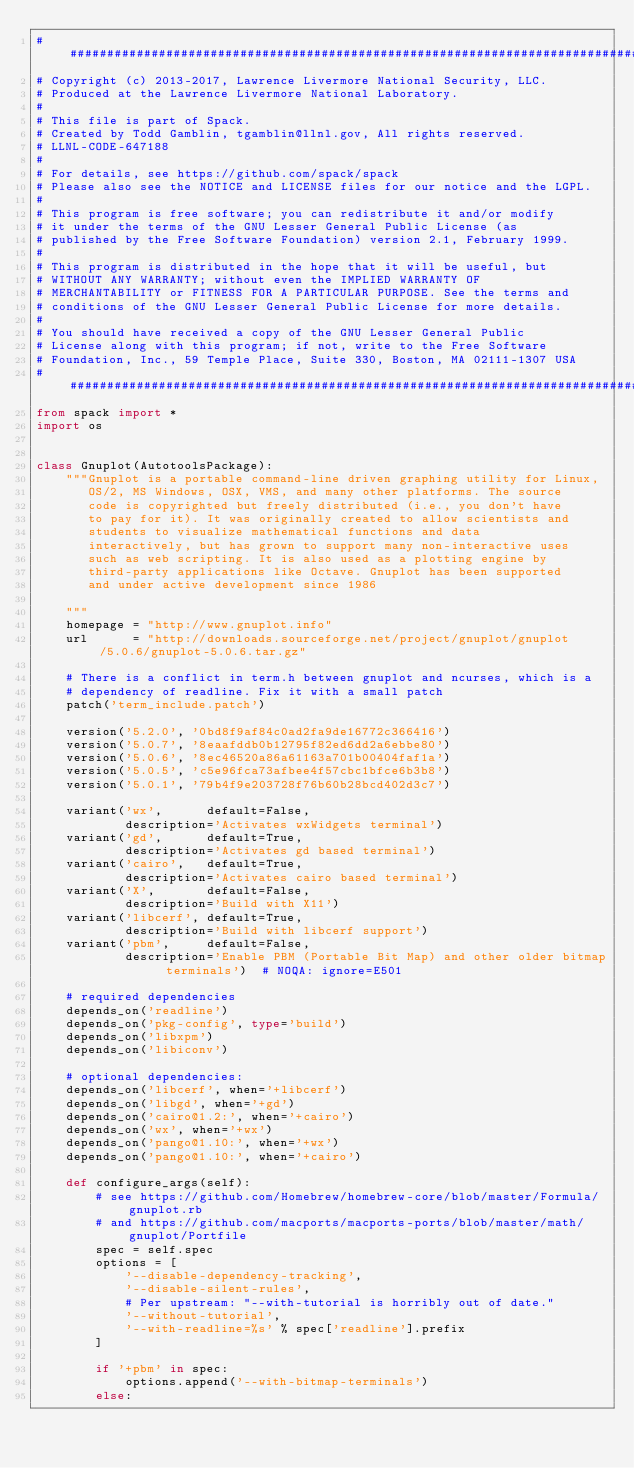Convert code to text. <code><loc_0><loc_0><loc_500><loc_500><_Python_>##############################################################################
# Copyright (c) 2013-2017, Lawrence Livermore National Security, LLC.
# Produced at the Lawrence Livermore National Laboratory.
#
# This file is part of Spack.
# Created by Todd Gamblin, tgamblin@llnl.gov, All rights reserved.
# LLNL-CODE-647188
#
# For details, see https://github.com/spack/spack
# Please also see the NOTICE and LICENSE files for our notice and the LGPL.
#
# This program is free software; you can redistribute it and/or modify
# it under the terms of the GNU Lesser General Public License (as
# published by the Free Software Foundation) version 2.1, February 1999.
#
# This program is distributed in the hope that it will be useful, but
# WITHOUT ANY WARRANTY; without even the IMPLIED WARRANTY OF
# MERCHANTABILITY or FITNESS FOR A PARTICULAR PURPOSE. See the terms and
# conditions of the GNU Lesser General Public License for more details.
#
# You should have received a copy of the GNU Lesser General Public
# License along with this program; if not, write to the Free Software
# Foundation, Inc., 59 Temple Place, Suite 330, Boston, MA 02111-1307 USA
##############################################################################
from spack import *
import os


class Gnuplot(AutotoolsPackage):
    """Gnuplot is a portable command-line driven graphing utility for Linux,
       OS/2, MS Windows, OSX, VMS, and many other platforms. The source
       code is copyrighted but freely distributed (i.e., you don't have
       to pay for it). It was originally created to allow scientists and
       students to visualize mathematical functions and data
       interactively, but has grown to support many non-interactive uses
       such as web scripting. It is also used as a plotting engine by
       third-party applications like Octave. Gnuplot has been supported
       and under active development since 1986

    """
    homepage = "http://www.gnuplot.info"
    url      = "http://downloads.sourceforge.net/project/gnuplot/gnuplot/5.0.6/gnuplot-5.0.6.tar.gz"

    # There is a conflict in term.h between gnuplot and ncurses, which is a
    # dependency of readline. Fix it with a small patch
    patch('term_include.patch')

    version('5.2.0', '0bd8f9af84c0ad2fa9de16772c366416')
    version('5.0.7', '8eaafddb0b12795f82ed6dd2a6ebbe80')
    version('5.0.6', '8ec46520a86a61163a701b00404faf1a')
    version('5.0.5', 'c5e96fca73afbee4f57cbc1bfce6b3b8')
    version('5.0.1', '79b4f9e203728f76b60b28bcd402d3c7')

    variant('wx',      default=False,
            description='Activates wxWidgets terminal')
    variant('gd',      default=True,
            description='Activates gd based terminal')
    variant('cairo',   default=True,
            description='Activates cairo based terminal')
    variant('X',       default=False,
            description='Build with X11')
    variant('libcerf', default=True,
            description='Build with libcerf support')
    variant('pbm',     default=False,
            description='Enable PBM (Portable Bit Map) and other older bitmap terminals')  # NOQA: ignore=E501

    # required dependencies
    depends_on('readline')
    depends_on('pkg-config', type='build')
    depends_on('libxpm')
    depends_on('libiconv')

    # optional dependencies:
    depends_on('libcerf', when='+libcerf')
    depends_on('libgd', when='+gd')
    depends_on('cairo@1.2:', when='+cairo')
    depends_on('wx', when='+wx')
    depends_on('pango@1.10:', when='+wx')
    depends_on('pango@1.10:', when='+cairo')

    def configure_args(self):
        # see https://github.com/Homebrew/homebrew-core/blob/master/Formula/gnuplot.rb
        # and https://github.com/macports/macports-ports/blob/master/math/gnuplot/Portfile
        spec = self.spec
        options = [
            '--disable-dependency-tracking',
            '--disable-silent-rules',
            # Per upstream: "--with-tutorial is horribly out of date."
            '--without-tutorial',
            '--with-readline=%s' % spec['readline'].prefix
        ]

        if '+pbm' in spec:
            options.append('--with-bitmap-terminals')
        else:</code> 